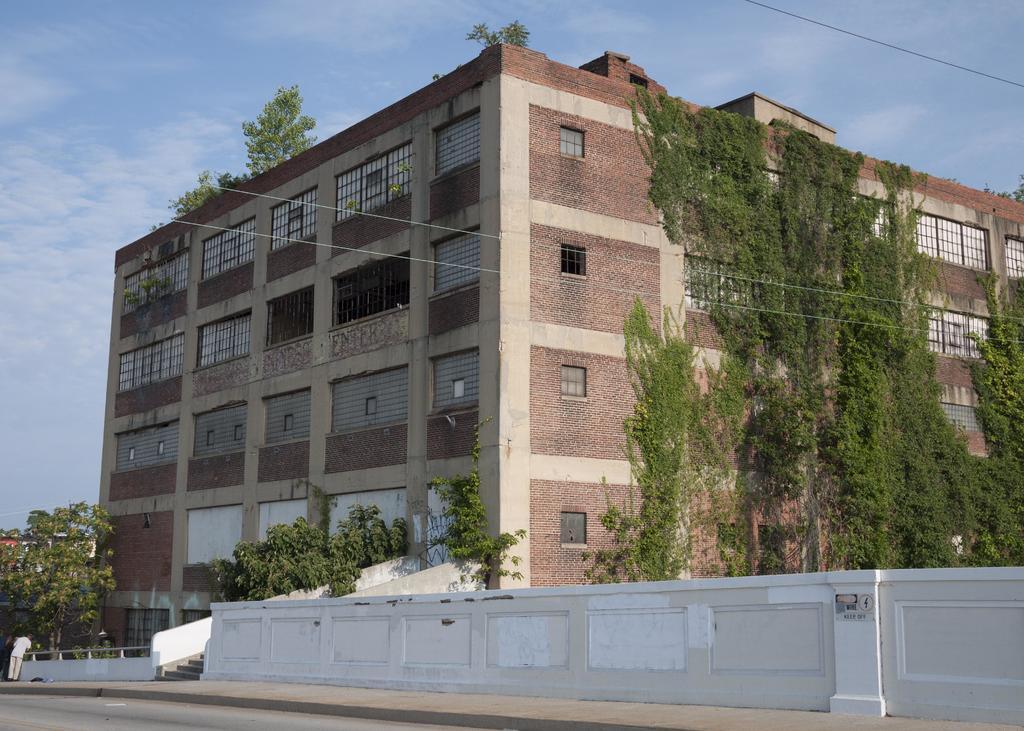How would you summarize this image in a sentence or two? In this image we can see the building, creepers, trees, wires, wall, stairs, path and also the road. We can also see a person on the left. In the background we can see the sky with some clouds. 